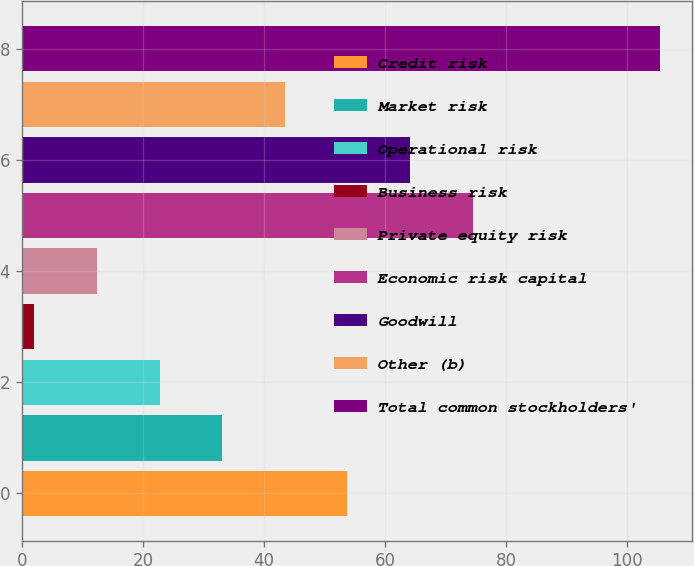<chart> <loc_0><loc_0><loc_500><loc_500><bar_chart><fcel>Credit risk<fcel>Market risk<fcel>Operational risk<fcel>Business risk<fcel>Private equity risk<fcel>Economic risk capital<fcel>Goodwill<fcel>Other (b)<fcel>Total common stockholders'<nl><fcel>53.8<fcel>33.12<fcel>22.78<fcel>2.1<fcel>12.44<fcel>74.48<fcel>64.14<fcel>43.46<fcel>105.5<nl></chart> 